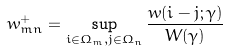<formula> <loc_0><loc_0><loc_500><loc_500>w ^ { + } _ { m n } = \sup _ { i \in \Omega _ { m } , j \in \Omega _ { n } } \frac { w ( i - j ; \gamma ) } { W ( \gamma ) }</formula> 